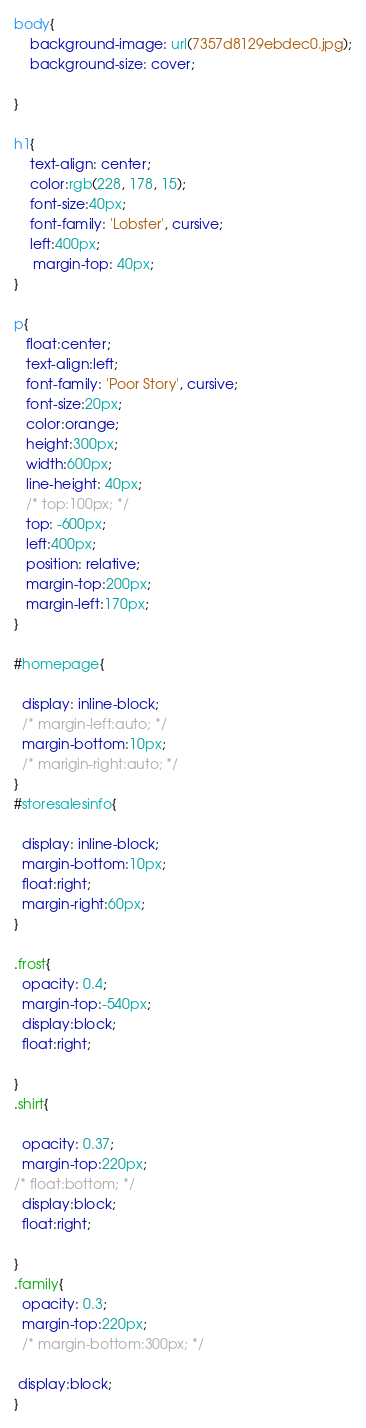Convert code to text. <code><loc_0><loc_0><loc_500><loc_500><_CSS_>body{
    background-image: url(7357d8129ebdec0.jpg);
    background-size: cover;
 
}

h1{
    text-align: center;
    color:rgb(228, 178, 15);
    font-size:40px;
    font-family: 'Lobster', cursive;
    left:400px;
     margin-top: 40px;
}
  
p{
   float:center;
   text-align:left;
   font-family: 'Poor Story', cursive;
   font-size:20px;
   color:orange;
   height:300px;
   width:600px;
   line-height: 40px;
   /* top:100px; */
   top: -600px;
   left:400px;
   position: relative;
   margin-top:200px;
   margin-left:170px;
}

#homepage{

  display: inline-block;
  /* margin-left:auto; */
  margin-bottom:10px;
  /* marigin-right:auto; */
}
#storesalesinfo{

  display: inline-block;
  margin-bottom:10px;
  float:right;
  margin-right:60px;
}

.frost{
  opacity: 0.4;
  margin-top:-540px;
  display:block;
  float:right;

}
.shirt{

  opacity: 0.37;
  margin-top:220px;
/* float:bottom; */
  display:block;
  float:right;

}
.family{
  opacity: 0.3;
  margin-top:220px;
  /* margin-bottom:300px; */

 display:block;
}
</code> 